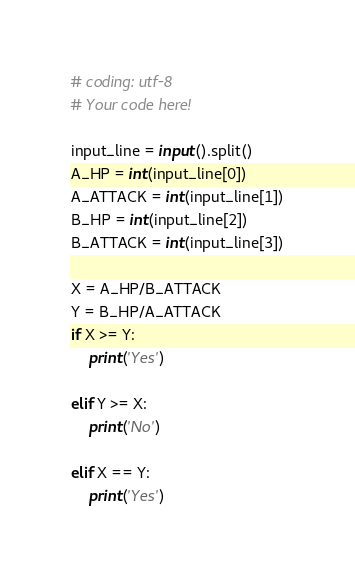<code> <loc_0><loc_0><loc_500><loc_500><_Python_># coding: utf-8
# Your code here!

input_line = input().split()
A_HP = int(input_line[0])
A_ATTACK = int(input_line[1])
B_HP = int(input_line[2])
B_ATTACK = int(input_line[3])

X = A_HP/B_ATTACK
Y = B_HP/A_ATTACK
if X >= Y:
    print('Yes')
    
elif Y >= X:
    print('No')
    
elif X == Y:
    print('Yes')</code> 